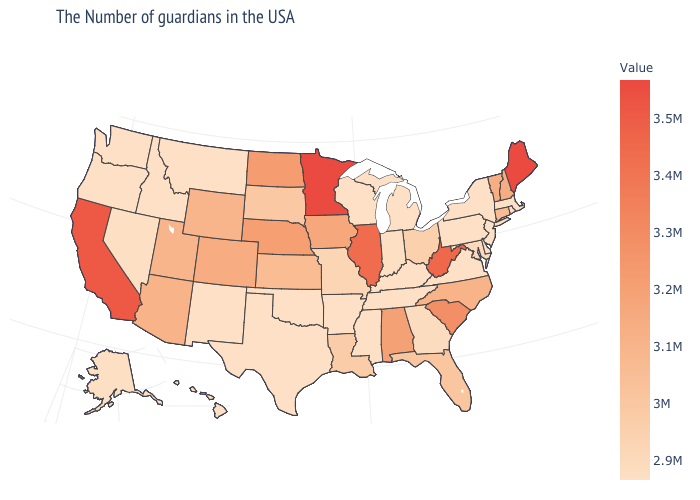Does Oregon have the lowest value in the West?
Be succinct. Yes. Does Kentucky have a lower value than South Carolina?
Short answer required. Yes. Which states have the lowest value in the USA?
Concise answer only. Massachusetts, Rhode Island, New York, New Jersey, Delaware, Pennsylvania, Virginia, Michigan, Kentucky, Tennessee, Wisconsin, Mississippi, Arkansas, Oklahoma, Texas, New Mexico, Montana, Idaho, Washington, Oregon, Hawaii. Which states hav the highest value in the West?
Quick response, please. California. Among the states that border Ohio , does Indiana have the lowest value?
Write a very short answer. No. 